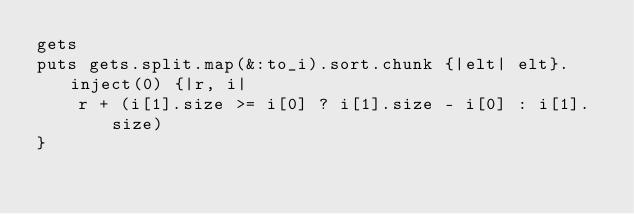Convert code to text. <code><loc_0><loc_0><loc_500><loc_500><_Ruby_>gets
puts gets.split.map(&:to_i).sort.chunk {|elt| elt}.inject(0) {|r, i|
    r + (i[1].size >= i[0] ? i[1].size - i[0] : i[1].size)
}</code> 